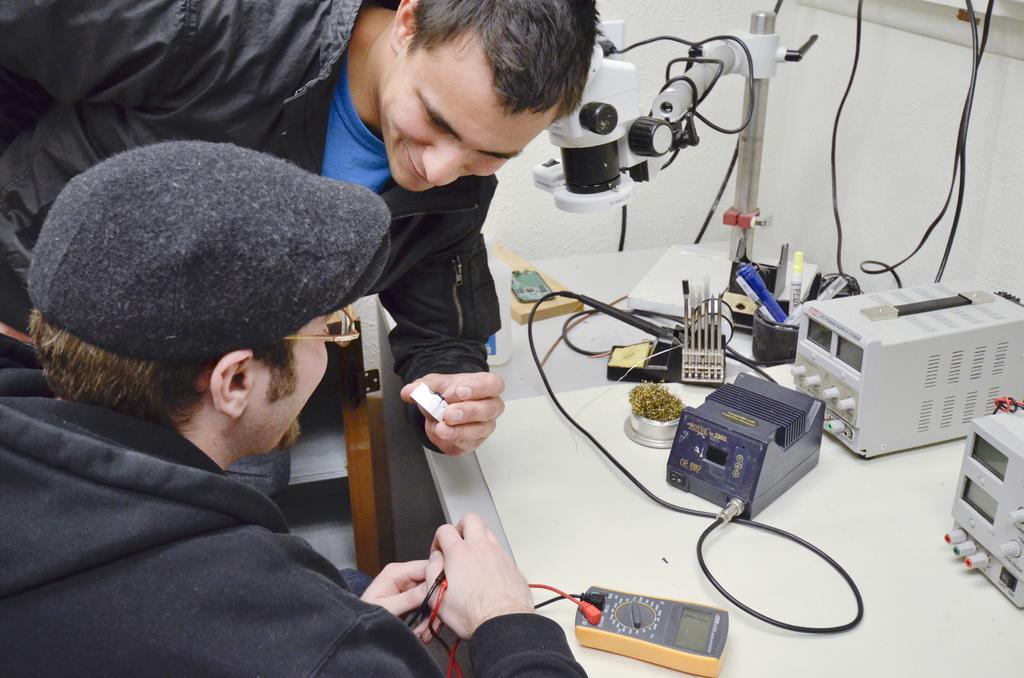Please provide a concise description of this image. On the right side of this image there is a table on which few electronic devices, cables, pens and some other objects are placed. On the left side there are two persons smiling. One person is holding a white color object in the hand and another person is holding cables. At the back of these people there is a small table. In the background there is a wall. 